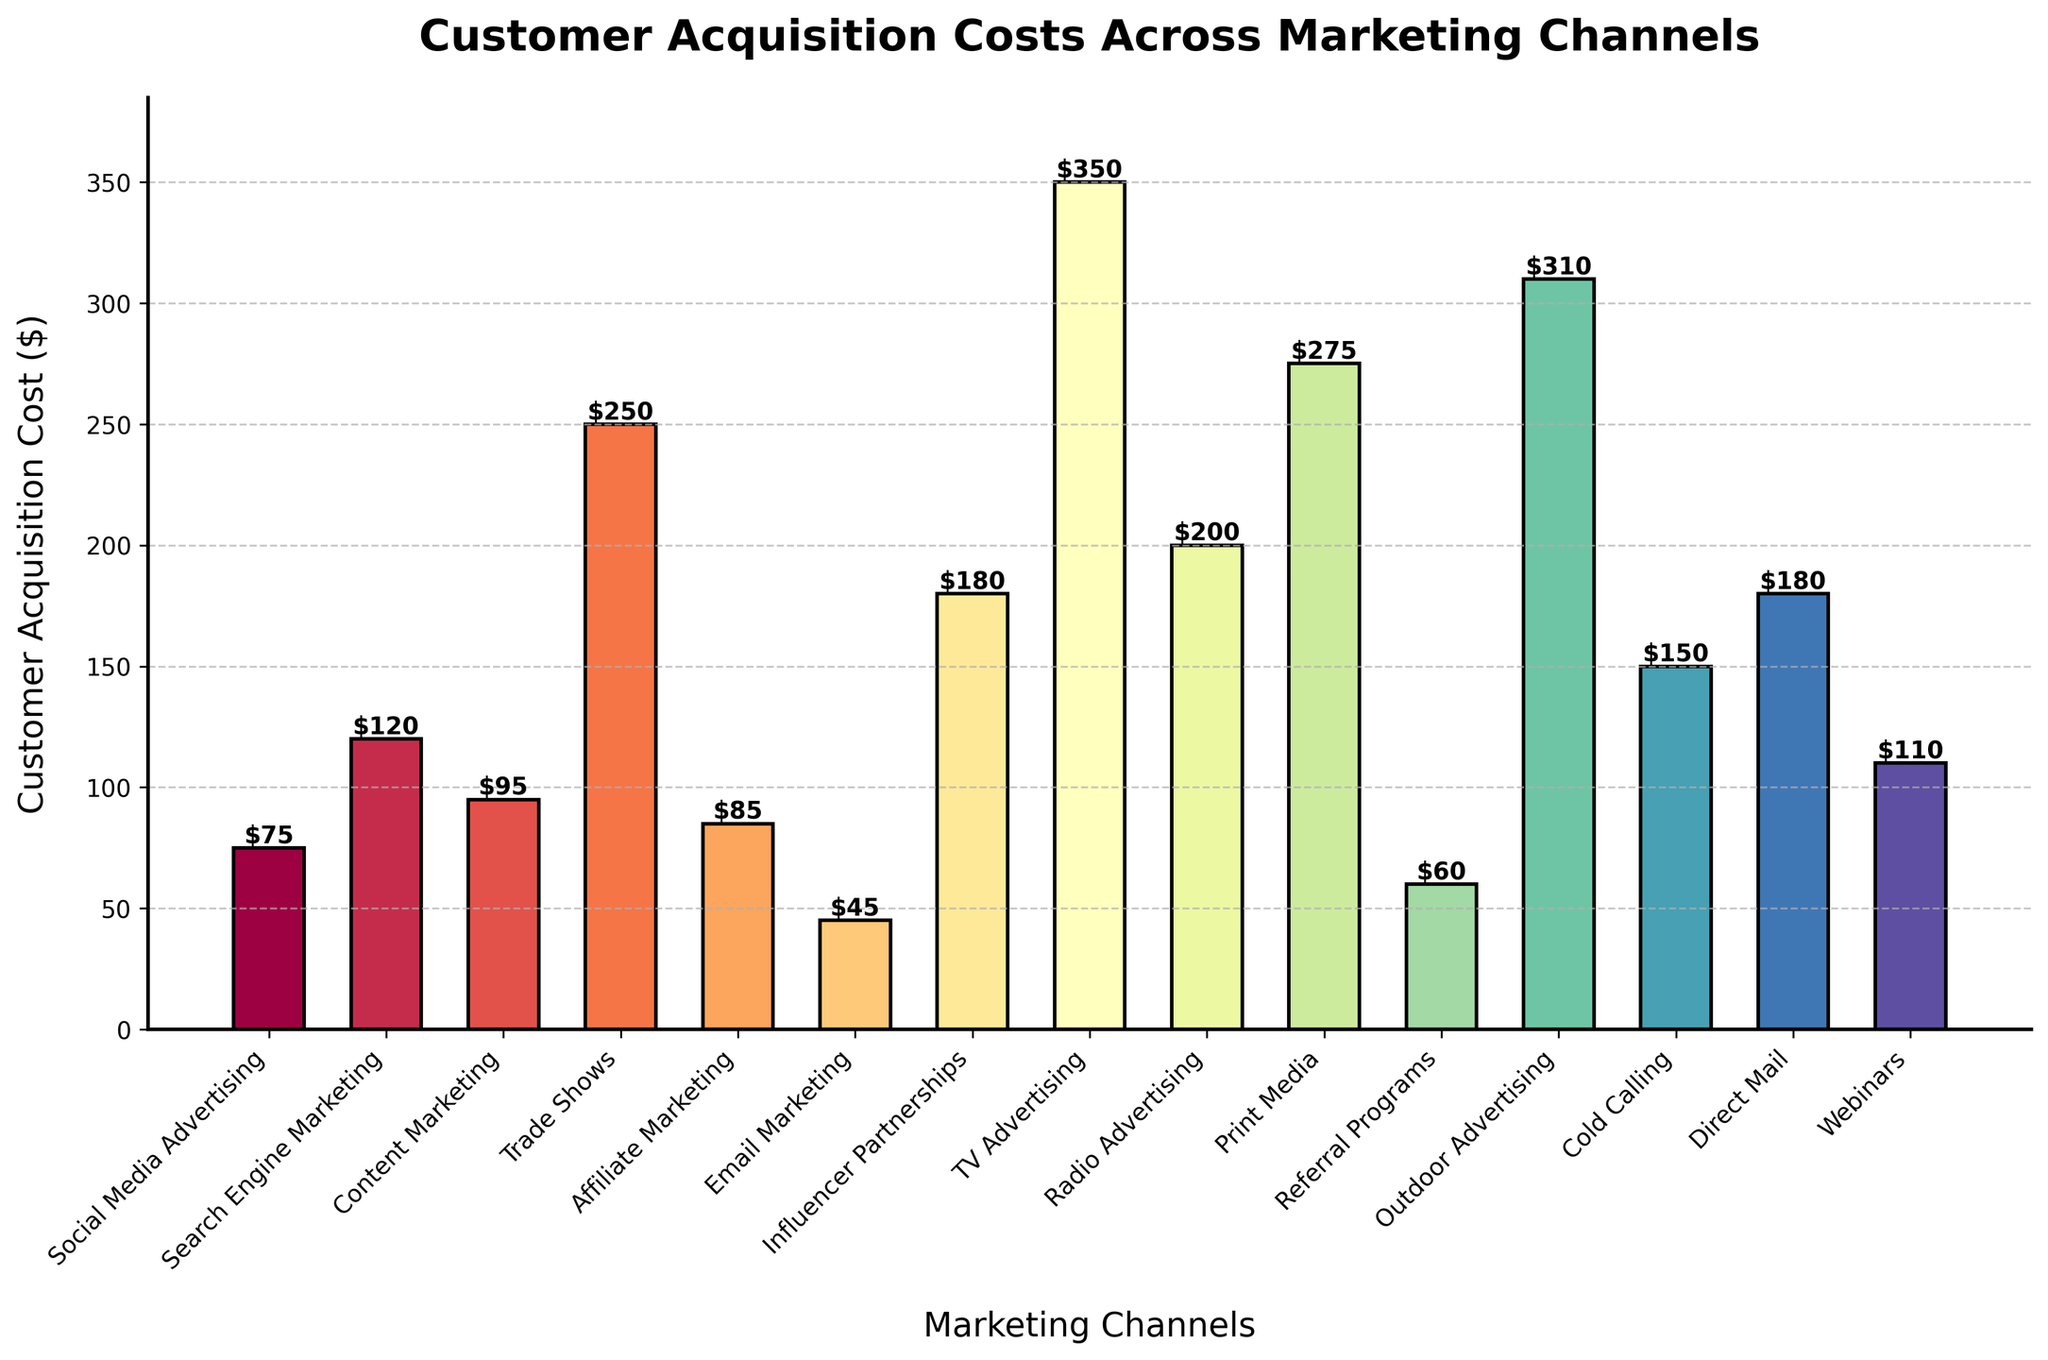what is the highest customer acquisition cost among the marketing channels? The highest acquisition cost can be identified by looking for the tallest bar in the chart. TV Advertising has the highest acquisition cost with a bar height representing $350.
Answer: $350 Which marketing channel has the lowest customer acquisition cost? The shortest bar represents the lowest acquisition cost. Email Marketing has the shortest bar, representing a cost of $45.
Answer: Email Marketing How much more expensive is TV Advertising compared to Trade Shows? Identify the cost for TV Advertising ($350) and Trade Shows ($250). Subtract the cost of Trade Shows from TV Advertising: $350 - $250 = $100.
Answer: $100 Which marketing channels have an acquisition cost greater than $200? Locate and list the bars with heights above $200. These are TV Advertising ($350), Radio Advertising ($200), Print Media ($275), and Outdoor Advertising ($310).
Answer: TV Advertising, Print Media, Outdoor Advertising What is the combined cost of Social Media Advertising, Search Engine Marketing, and Email Marketing? Sum up the costs for these channels: Social Media Advertising ($75), Search Engine Marketing ($120), and Email Marketing ($45). The combined cost is $75 + $120 + $45 = $240.
Answer: $240 What is the difference in customer acquisition cost between the two forms of media advertising, TV, and Radio? Identify the costs for TV Advertising ($350) and Radio Advertising ($200). Subtract Radio Advertising's cost from TV Advertising's cost: $350 - $200 = $150.
Answer: $150 Which marketing channel's customer acquisition cost is closest to the average cost of all channels? First, calculate the average cost: Sum all channel costs and divide by the number of channels. ($75 + $120 + $95 + $250 + $85 + $45 + $180 + $350 + $200 + $275 + $60 + $310 + $150 + $180 + $110) / 15 = $168. The closest value is Direct Mail ($180).
Answer: Direct Mail How do the costs of Affiliate Marketing and Content Marketing compare? Identify the costs for Affiliate Marketing ($85) and Content Marketing ($95). Content Marketing is $10 more expensive than Affiliate Marketing as $95 - $85 = $10.
Answer: Content Marketing is $10 more expensive Which marketing channel has a customer acquisition cost represented by a purple-colored bar? Visually identify the bar colored purple, corresponding to Search Engine Marketing, with a cost of $120.
Answer: Search Engine Marketing What is the average customer acquisition cost across all marketing channels? Sum all costs and divide by the number of channels: ($75 + $120 + $95 + $250 + $85 + $45 + $180 + $350 + $200 + $275 + $60 + $310 + $150 + $180 + $110) / 15 = $168.
Answer: $168 